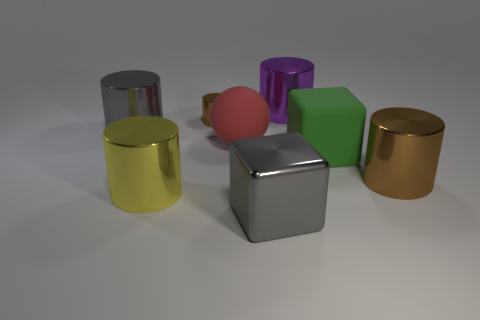Are there fewer rubber objects than green matte cubes?
Offer a terse response. No. There is a gray thing that is left of the large block left of the big green cube; what is its shape?
Your answer should be compact. Cylinder. Are there any other things that have the same size as the green rubber thing?
Your answer should be very brief. Yes. The large gray thing behind the gray shiny thing that is in front of the big cube that is behind the large brown metal cylinder is what shape?
Your answer should be compact. Cylinder. How many things are large blocks that are right of the purple cylinder or large rubber objects that are to the left of the large purple metallic cylinder?
Offer a terse response. 2. There is a yellow metallic cylinder; is it the same size as the brown metallic cylinder in front of the large gray cylinder?
Your response must be concise. Yes. Is the material of the big cylinder right of the large green cube the same as the gray thing right of the tiny shiny object?
Ensure brevity in your answer.  Yes. Is the number of large matte spheres behind the big red thing the same as the number of metal objects on the right side of the large yellow metallic thing?
Ensure brevity in your answer.  No. How many large balls have the same color as the tiny object?
Provide a short and direct response. 0. There is a large cylinder that is the same color as the shiny cube; what is its material?
Ensure brevity in your answer.  Metal. 